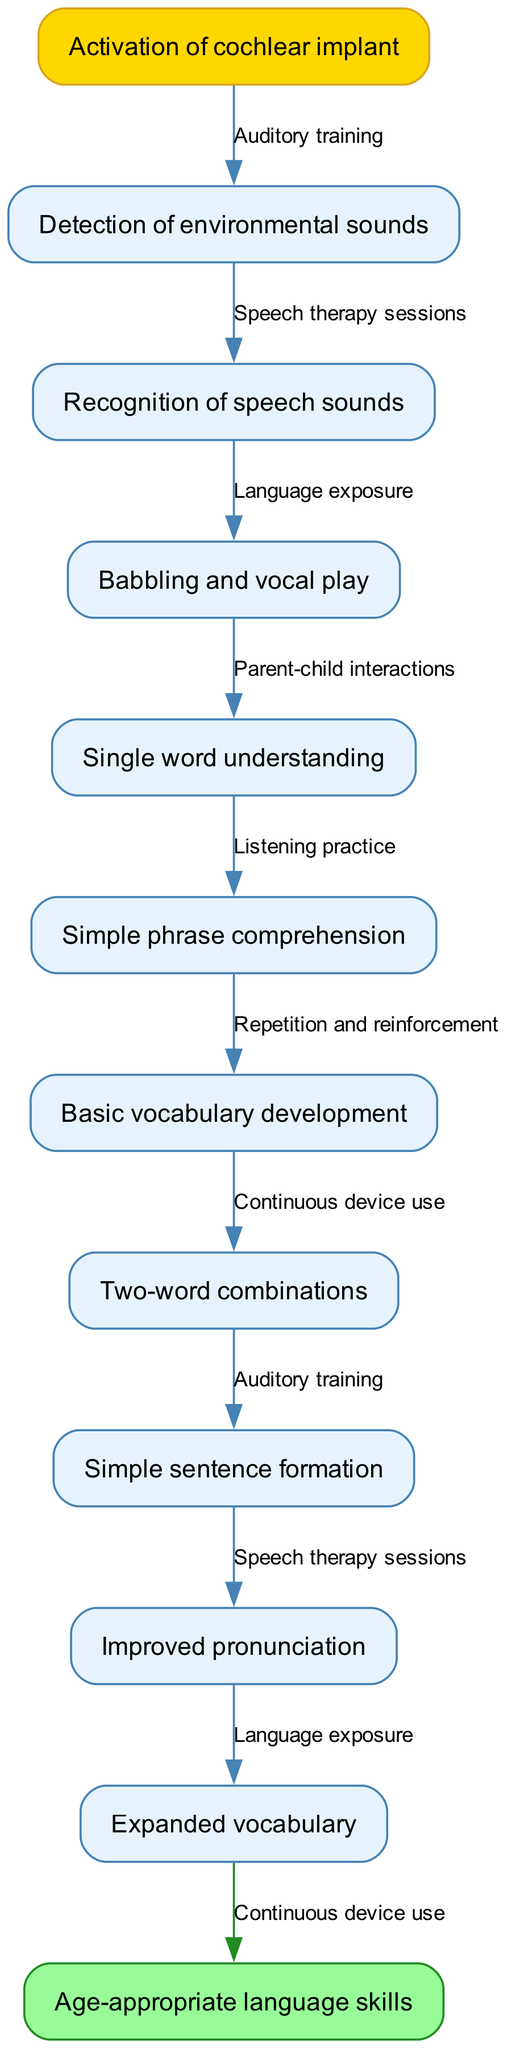What's the starting point of the diagram? The starting point is "Activation of cochlear implant," which serves as the initial node in the flow of speech and language development.
Answer: Activation of cochlear implant How many intermediate nodes are in the diagram? There are ten intermediate nodes listed in the diagram that represent different stages of speech and language development.
Answer: 10 What is the last stage before reaching "Age-appropriate language skills"? The last stage before reaching the final goal is "Expanded vocabulary," which is the final intermediate node before the end node.
Answer: Expanded vocabulary Which edge connects "Detection of environmental sounds" to the next node? "Auditory training" is the edge that connects "Detection of environmental sounds" to the next node, representing the first step in the developmental process after activation.
Answer: Auditory training What is the relationship between "Single word understanding" and "Babbling and vocal play"? "Single word understanding" follows "Babbling and vocal play" in the flowchart, indicating that babbling is an early stage that leads to the understanding of single words.
Answer: Follows What is the effect of "Continuous device use" in this progression? "Continuous device use" is important as it links to the last edge in the diagram, showing it is essential for achieving age-appropriate language skills.
Answer: Essential What type of activities are combined with "Parent-child interactions"? "Parent-child interactions" are part of "Language exposure," which suggests that engaging with caregivers boosts the child's language development.
Answer: Language exposure How does "Listening practice" connect to the development of "Two-word combinations"? "Listening practice" is a step that precedes "Two-word combinations," indicating that listening skills are crucial for progressing to forming two-word phrases.
Answer: Precedes What is the main outcome of the process depicted in the diagram? The main outcome of the process illustrated is "Age-appropriate language skills," which represents the ultimate goal of the developmental journey.
Answer: Age-appropriate language skills 